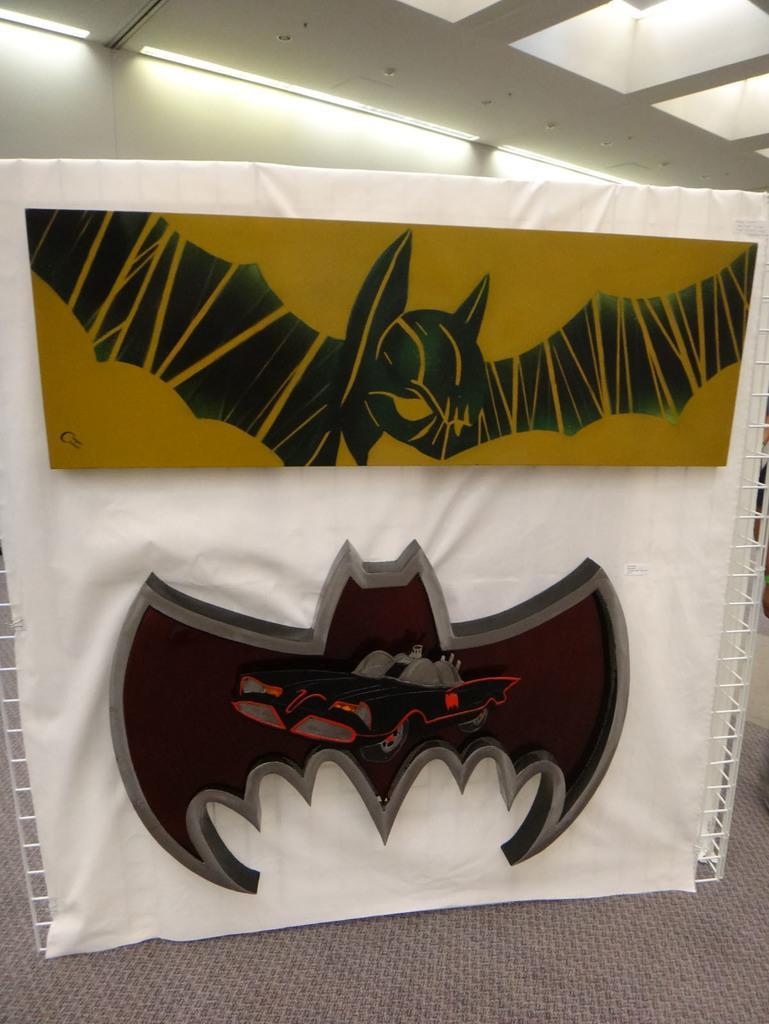Describe this image in one or two sentences. In this picture we can see a bat logo and a board on a white cloth. It looks like the steel grilles and on the steel grilles there is the white cloth. Behind the steel grilles there is a wall and at the top there are ceiling lights. 